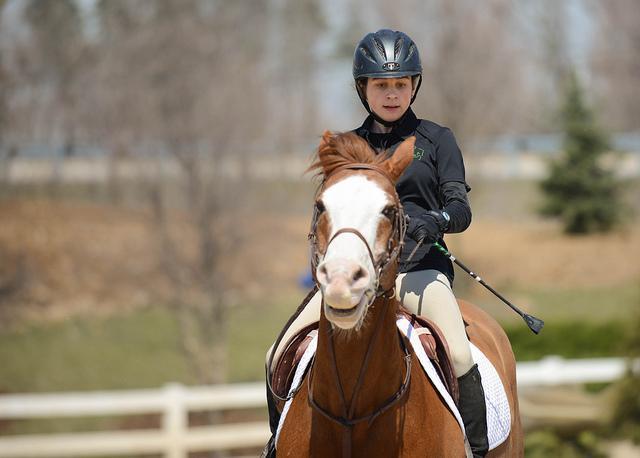How many giraffes are there?
Give a very brief answer. 0. 